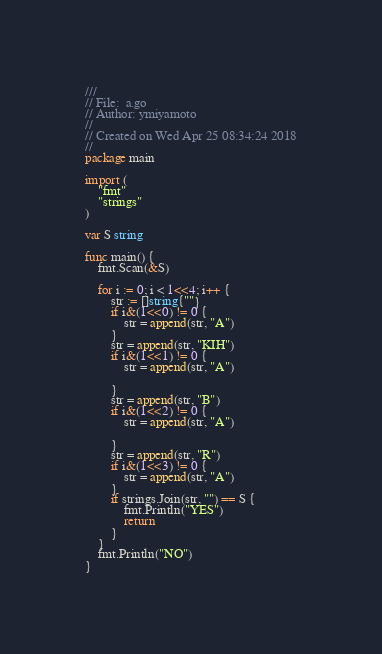Convert code to text. <code><loc_0><loc_0><loc_500><loc_500><_Go_>///
// File:  a.go
// Author: ymiyamoto
//
// Created on Wed Apr 25 08:34:24 2018
//
package main

import (
	"fmt"
	"strings"
)

var S string

func main() {
	fmt.Scan(&S)

	for i := 0; i < 1<<4; i++ {
		str := []string{""}
		if i&(1<<0) != 0 {
			str = append(str, "A")
		}
		str = append(str, "KIH")
		if i&(1<<1) != 0 {
			str = append(str, "A")

		}
		str = append(str, "B")
		if i&(1<<2) != 0 {
			str = append(str, "A")

		}
		str = append(str, "R")
		if i&(1<<3) != 0 {
			str = append(str, "A")
		}
		if strings.Join(str, "") == S {
			fmt.Println("YES")
			return
		}
	}
	fmt.Println("NO")
}
</code> 